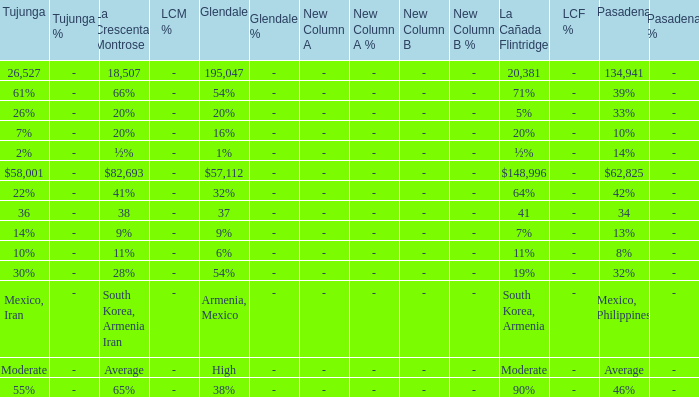What is the pasadena value when tujunga's is 36? 34.0. 